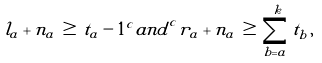Convert formula to latex. <formula><loc_0><loc_0><loc_500><loc_500>l _ { a } + n _ { a } \, \geq \, t _ { a } - 1 ^ { c } { a n d } ^ { c } r _ { a } + n _ { a } \, \geq \, \sum _ { b = a } ^ { k } t _ { b } \, ,</formula> 